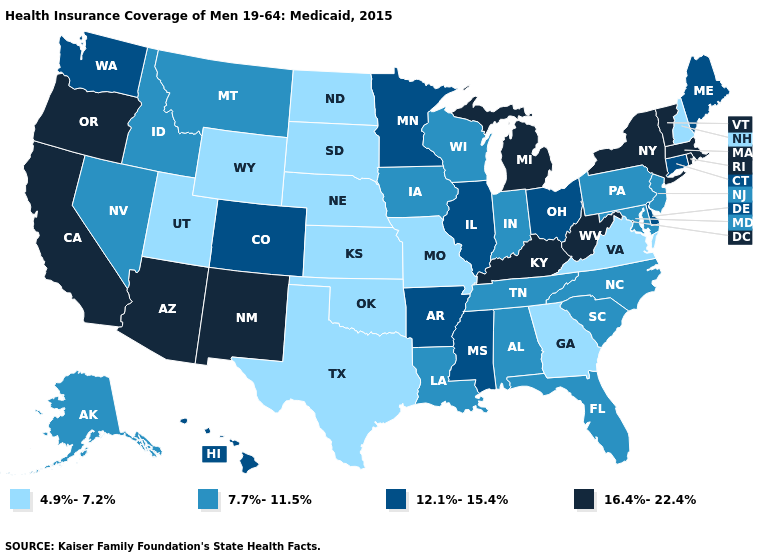What is the lowest value in states that border Kansas?
Short answer required. 4.9%-7.2%. Name the states that have a value in the range 4.9%-7.2%?
Give a very brief answer. Georgia, Kansas, Missouri, Nebraska, New Hampshire, North Dakota, Oklahoma, South Dakota, Texas, Utah, Virginia, Wyoming. What is the highest value in the USA?
Short answer required. 16.4%-22.4%. What is the value of Virginia?
Give a very brief answer. 4.9%-7.2%. What is the value of Virginia?
Concise answer only. 4.9%-7.2%. What is the value of Arkansas?
Give a very brief answer. 12.1%-15.4%. Name the states that have a value in the range 16.4%-22.4%?
Concise answer only. Arizona, California, Kentucky, Massachusetts, Michigan, New Mexico, New York, Oregon, Rhode Island, Vermont, West Virginia. Which states have the lowest value in the West?
Be succinct. Utah, Wyoming. What is the value of Utah?
Write a very short answer. 4.9%-7.2%. Does North Dakota have the lowest value in the USA?
Concise answer only. Yes. What is the value of Missouri?
Quick response, please. 4.9%-7.2%. Name the states that have a value in the range 7.7%-11.5%?
Concise answer only. Alabama, Alaska, Florida, Idaho, Indiana, Iowa, Louisiana, Maryland, Montana, Nevada, New Jersey, North Carolina, Pennsylvania, South Carolina, Tennessee, Wisconsin. What is the lowest value in states that border Wyoming?
Quick response, please. 4.9%-7.2%. Does Tennessee have the highest value in the South?
Keep it brief. No. What is the value of North Carolina?
Answer briefly. 7.7%-11.5%. 